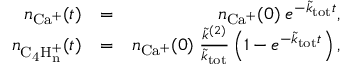<formula> <loc_0><loc_0><loc_500><loc_500>\begin{array} { r l r } { n _ { C a ^ { + } } ( t ) } & { = } & { n _ { C a ^ { + } } ( 0 ) \, e ^ { - \tilde { k } _ { t o t } t } , } \\ { n _ { C _ { 4 } H _ { n } ^ { + } } ( t ) } & { = } & { n _ { C a ^ { + } } ( 0 ) \, \frac { \tilde { k } ^ { ( 2 ) } } { \tilde { k } _ { t o t } } \left ( 1 - e ^ { - \tilde { k } _ { t o t } t } \right ) , } \end{array}</formula> 